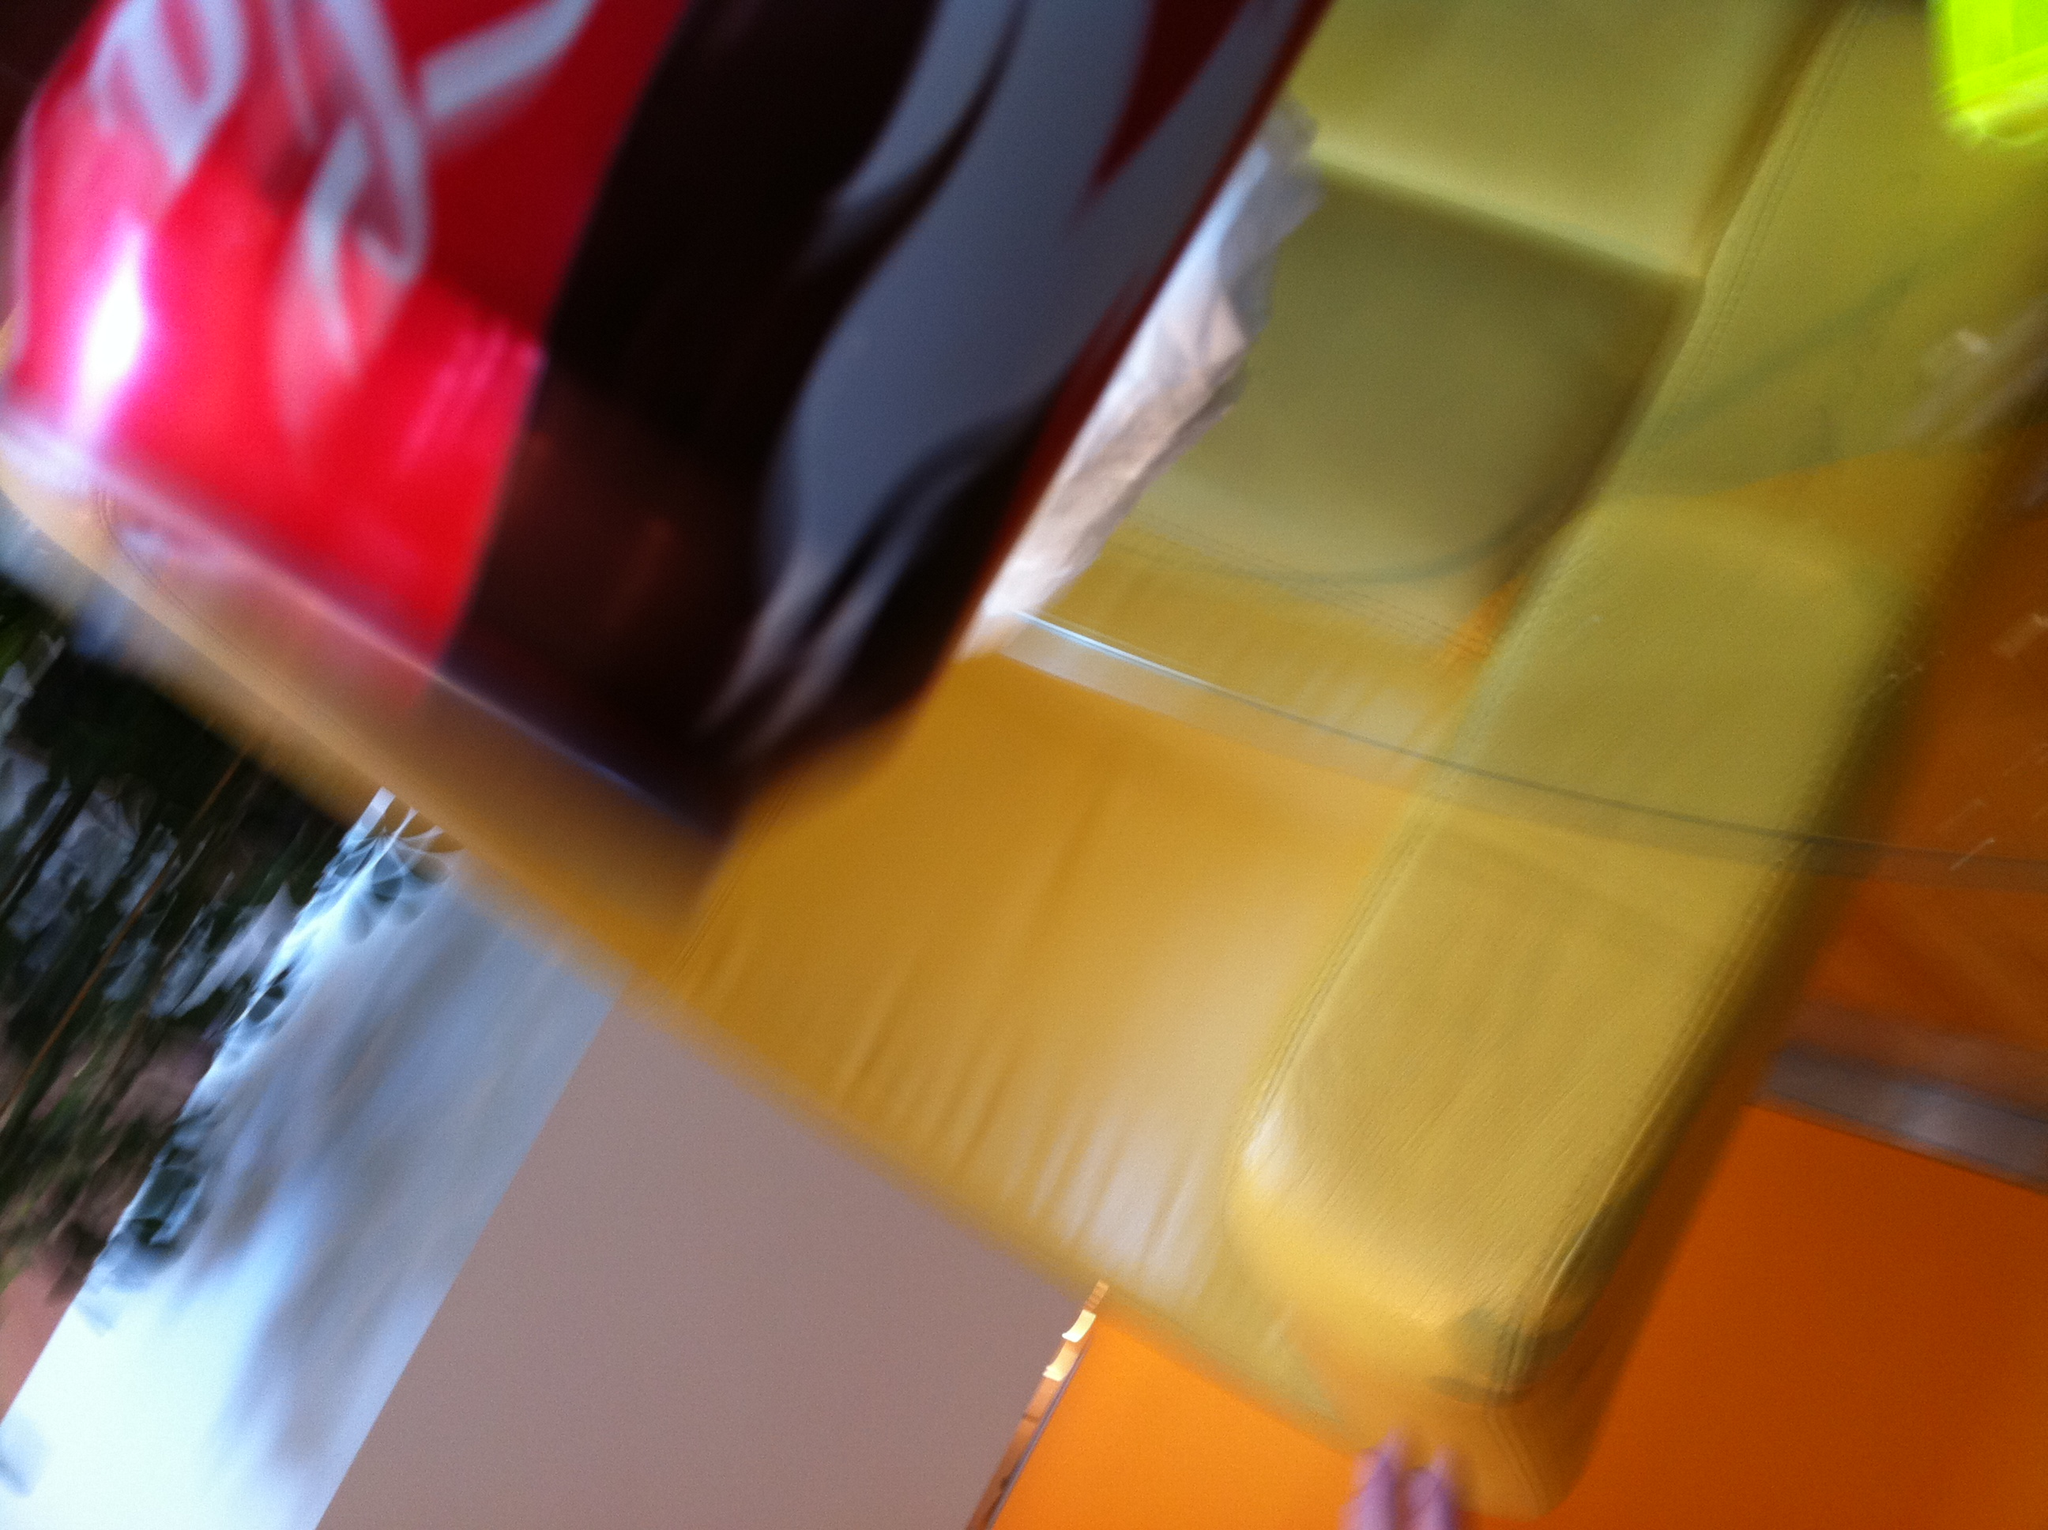Can you describe the setting where the Coca-Cola is placed? The Coca-Cola can appears to be suspended in a brightly lit environment, possibly indoors, with a blurry backdrop that might suggest motion or a quick snapshot. The surroundings include warm tones that could be either indoor furnishings or blurred lights. 